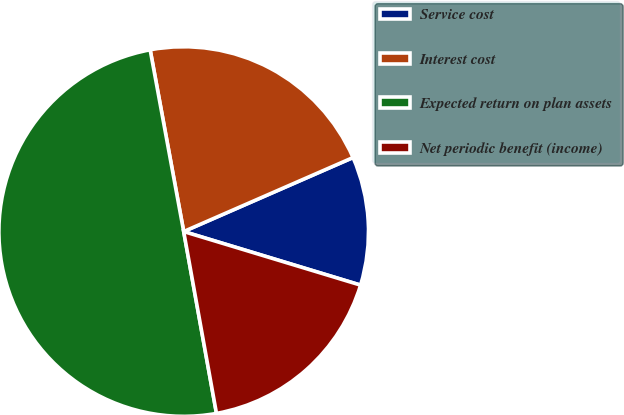Convert chart to OTSL. <chart><loc_0><loc_0><loc_500><loc_500><pie_chart><fcel>Service cost<fcel>Interest cost<fcel>Expected return on plan assets<fcel>Net periodic benefit (income)<nl><fcel>11.24%<fcel>21.35%<fcel>49.94%<fcel>17.48%<nl></chart> 